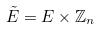Convert formula to latex. <formula><loc_0><loc_0><loc_500><loc_500>\tilde { E } = E \times \mathbb { Z } _ { n }</formula> 